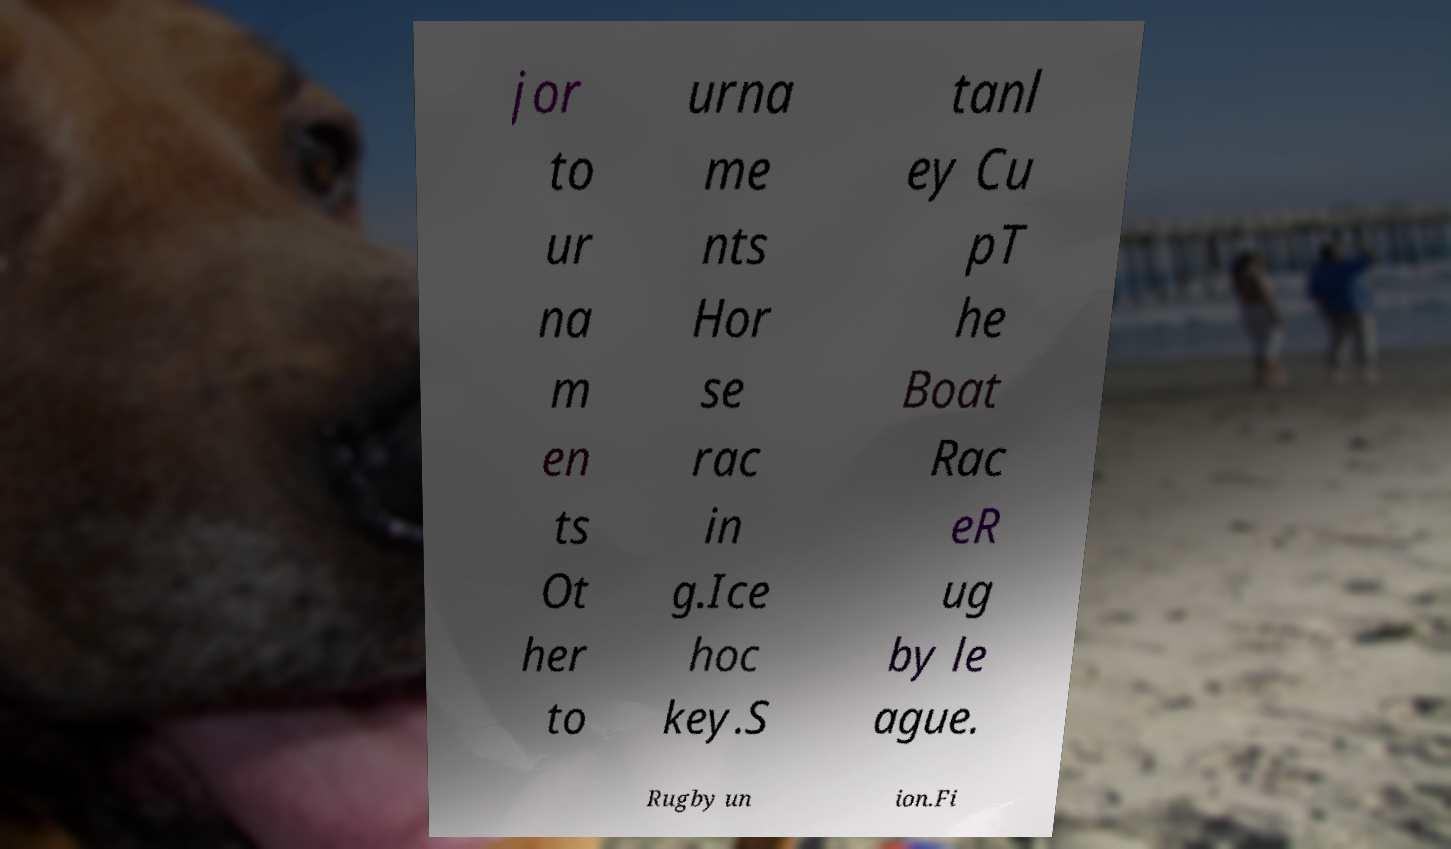Could you extract and type out the text from this image? jor to ur na m en ts Ot her to urna me nts Hor se rac in g.Ice hoc key.S tanl ey Cu pT he Boat Rac eR ug by le ague. Rugby un ion.Fi 